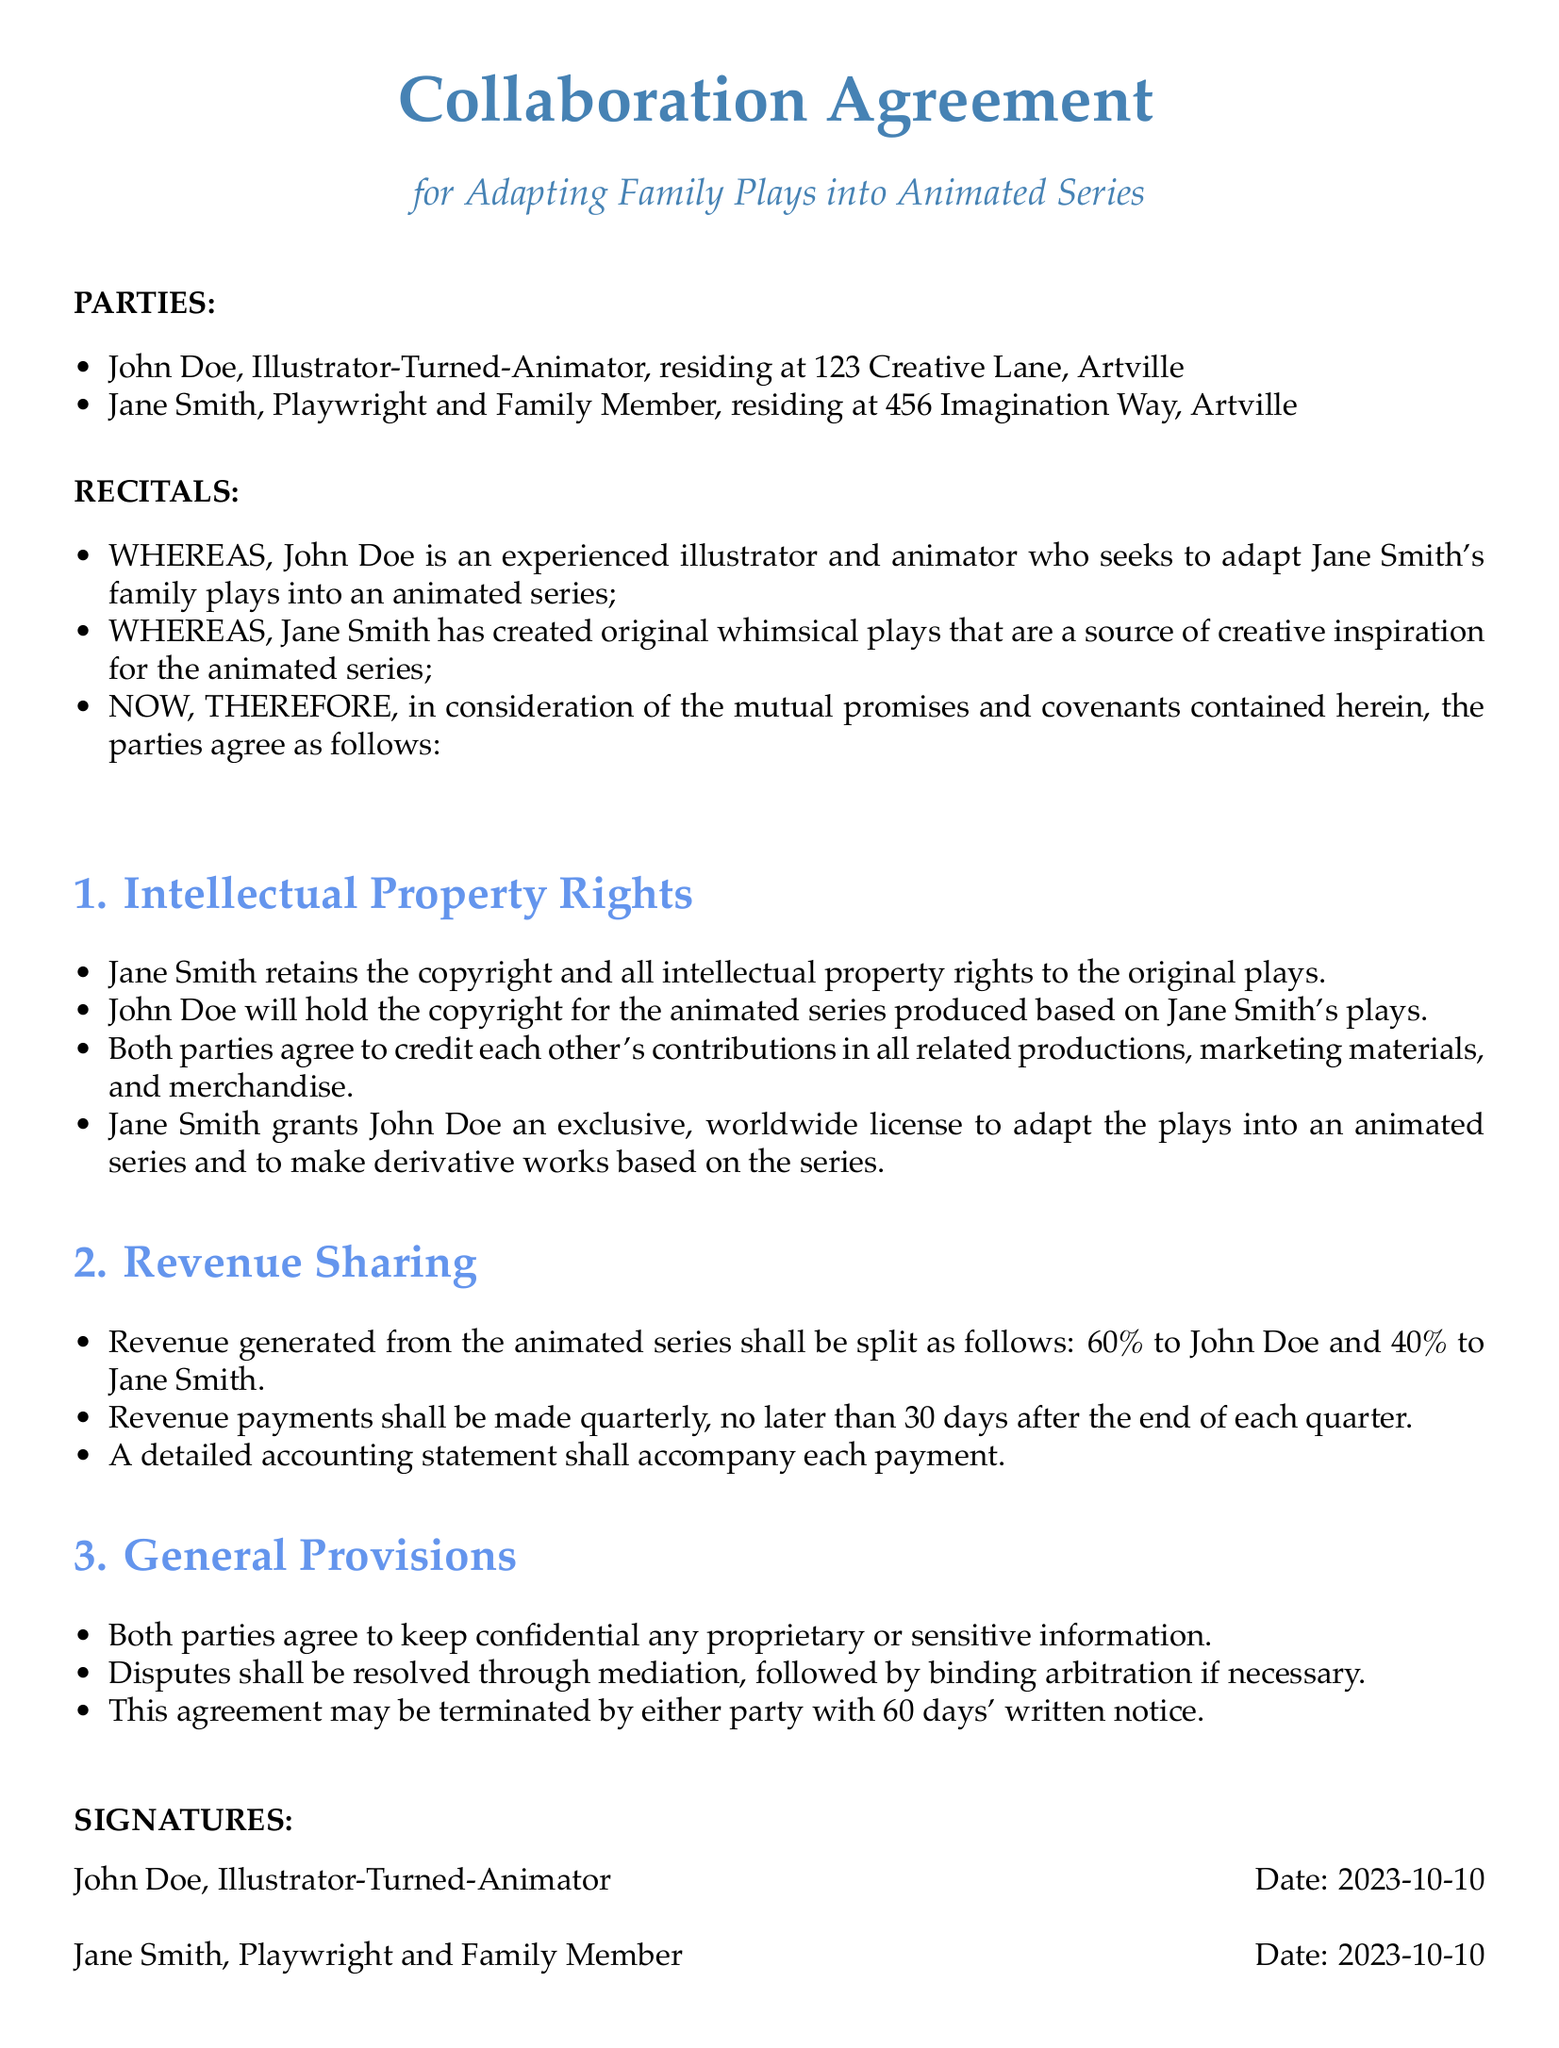What is the title of the agreement? The title of the agreement is stated at the beginning of the document, indicating the purpose of the contract.
Answer: Collaboration Agreement for Adapting Family Plays into Animated Series Who are the parties involved in the agreement? The parties involved are listed in the beginning section, identifying them clearly.
Answer: John Doe and Jane Smith What percentage of revenue does John Doe receive? The revenue sharing section specifies the distribution of revenue between the parties.
Answer: 60% What is Jane Smith's role in this agreement? The document describes Jane Smith's contributions in terms of her creative works in the initial section.
Answer: Playwright and Family Member How often will revenue payments be made? The document specifies the timing of revenue payments in the revenue sharing section.
Answer: Quarterly What kind of license does Jane Smith grant to John Doe? The intellectual property rights section details the specific type of license granted for adaptations.
Answer: Exclusive, worldwide license What must accompany each revenue payment? The revenue sharing section mentions the documentation required with each payment.
Answer: Detailed accounting statement What action can terminate the agreement? The general provisions section outlines the method for termination of the agreement.
Answer: 60 days' written notice 